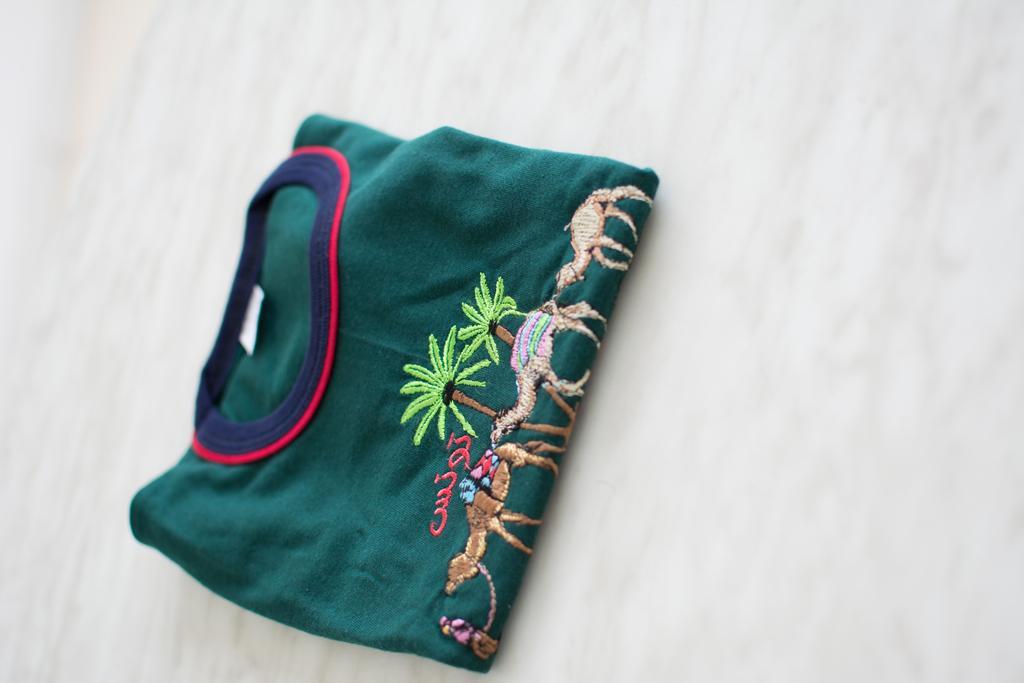In one or two sentences, can you explain what this image depicts? In this picture I can see a t-shirt in the middle, there is an embroidery work on it. 